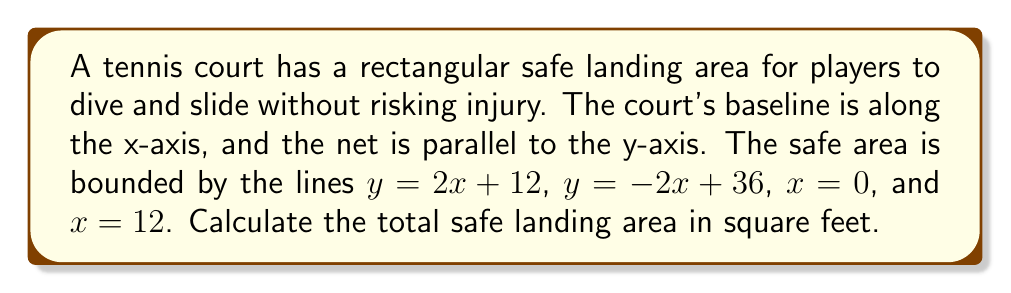Give your solution to this math problem. To determine the safe landing area, we need to follow these steps:

1) First, let's visualize the area:
[asy]
import geometry;

size(200);
defaultpen(fontsize(10pt));

draw((0,0)--(12,0)--(12,36)--(0,36)--cycle);
draw((0,12)--(12,36), blue);
draw((0,36)--(12,12), red);

label("y = 2x + 12", (6,24), NE, blue);
label("y = -2x + 36", (6,24), NW, red);
label("x = 0", (0,18), W);
label("x = 12", (12,18), E);

dot((0,12));
dot((0,36));
dot((12,12));
dot((12,36));

label("A", (0,12), SW);
label("B", (0,36), NW);
label("C", (12,36), NE);
label("D", (12,12), SE);
[/asy]

2) The area is a trapezoid ABCD. To calculate its area, we need its height and the lengths of the parallel sides.

3) The height is the difference in x-coordinates: $12 - 0 = 12$ feet.

4) For the parallel sides:
   At $x = 0$: 
   $y = 2(0) + 12 = 12$ and $y = -2(0) + 36 = 36$
   At $x = 12$: 
   $y = 2(12) + 12 = 36$ and $y = -2(12) + 36 = 12$

5) The lengths of the parallel sides are:
   $AB = 36 - 12 = 24$ feet
   $DC = 36 - 12 = 24$ feet

6) The area of a trapezoid is given by the formula:
   $$A = \frac{1}{2}(b_1 + b_2)h$$
   where $b_1$ and $b_2$ are the lengths of the parallel sides and $h$ is the height.

7) Substituting our values:
   $$A = \frac{1}{2}(24 + 24) \cdot 12$$
   $$A = \frac{1}{2} \cdot 48 \cdot 12$$
   $$A = 24 \cdot 12 = 288$$

Therefore, the total safe landing area is 288 square feet.
Answer: 288 sq ft 